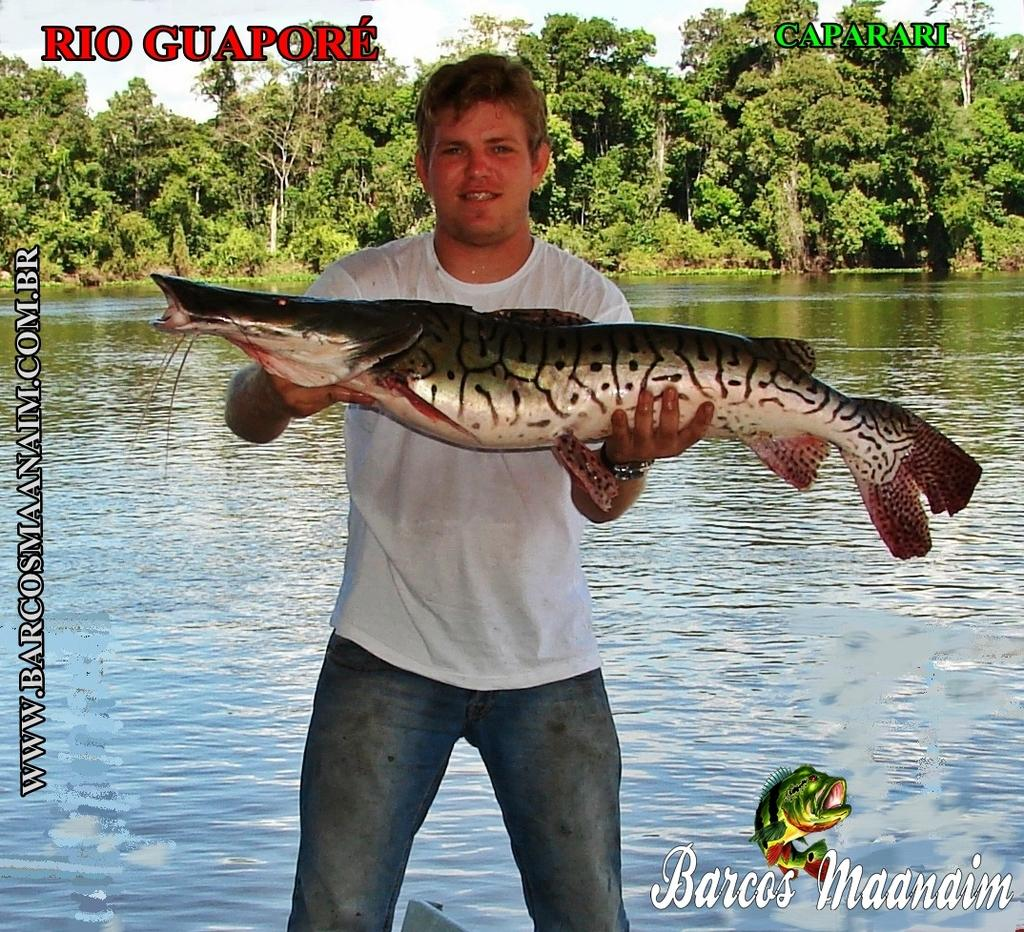What is the person in the image holding? The person is holding a fish. What can be seen in the background of the image? There is water, trees, and the sky visible in the background of the image. Are there any watermarks on the image? Yes, there are watermarks on the image. What type of faucet can be seen in the image? There is no faucet present in the image. How much debt does the person holding the fish have in the image? There is no information about the person's debt in the image. 